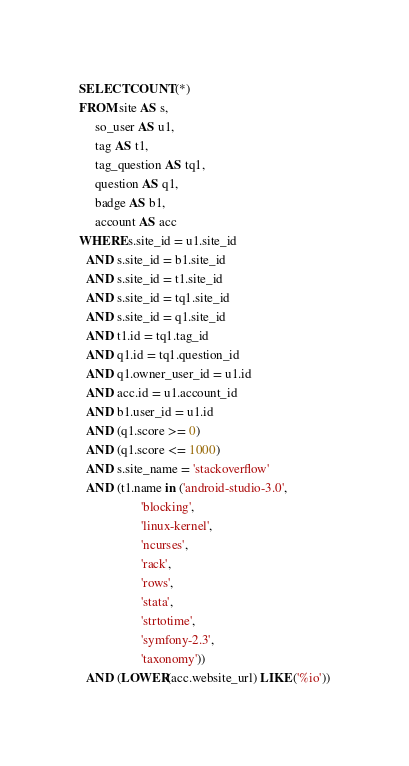<code> <loc_0><loc_0><loc_500><loc_500><_SQL_>SELECT COUNT(*)
FROM site AS s,
     so_user AS u1,
     tag AS t1,
     tag_question AS tq1,
     question AS q1,
     badge AS b1,
     account AS acc
WHERE s.site_id = u1.site_id
  AND s.site_id = b1.site_id
  AND s.site_id = t1.site_id
  AND s.site_id = tq1.site_id
  AND s.site_id = q1.site_id
  AND t1.id = tq1.tag_id
  AND q1.id = tq1.question_id
  AND q1.owner_user_id = u1.id
  AND acc.id = u1.account_id
  AND b1.user_id = u1.id
  AND (q1.score >= 0)
  AND (q1.score <= 1000)
  AND s.site_name = 'stackoverflow'
  AND (t1.name in ('android-studio-3.0',
                   'blocking',
                   'linux-kernel',
                   'ncurses',
                   'rack',
                   'rows',
                   'stata',
                   'strtotime',
                   'symfony-2.3',
                   'taxonomy'))
  AND (LOWER(acc.website_url) LIKE ('%io'))</code> 